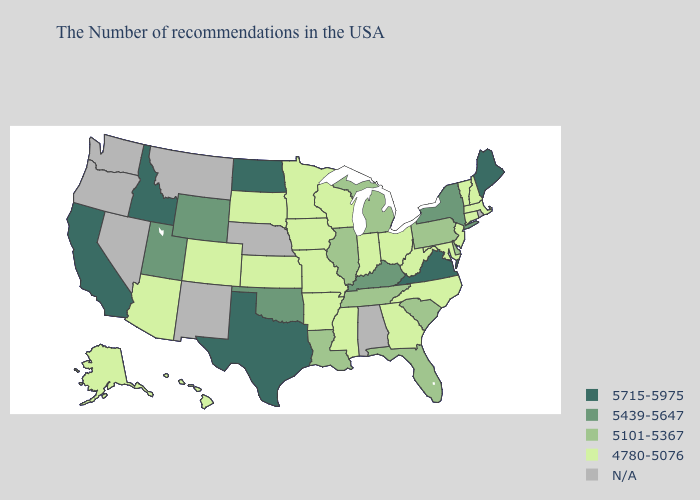Name the states that have a value in the range 5101-5367?
Give a very brief answer. Delaware, Pennsylvania, South Carolina, Florida, Michigan, Tennessee, Illinois, Louisiana. Name the states that have a value in the range 5439-5647?
Be succinct. New York, Kentucky, Oklahoma, Wyoming, Utah. Name the states that have a value in the range 5439-5647?
Write a very short answer. New York, Kentucky, Oklahoma, Wyoming, Utah. What is the lowest value in states that border Virginia?
Answer briefly. 4780-5076. Does Louisiana have the lowest value in the USA?
Keep it brief. No. Among the states that border Oklahoma , which have the highest value?
Answer briefly. Texas. What is the value of Ohio?
Quick response, please. 4780-5076. What is the highest value in states that border Michigan?
Write a very short answer. 4780-5076. What is the value of Wisconsin?
Short answer required. 4780-5076. Does the first symbol in the legend represent the smallest category?
Keep it brief. No. Name the states that have a value in the range 4780-5076?
Short answer required. Massachusetts, New Hampshire, Vermont, Connecticut, New Jersey, Maryland, North Carolina, West Virginia, Ohio, Georgia, Indiana, Wisconsin, Mississippi, Missouri, Arkansas, Minnesota, Iowa, Kansas, South Dakota, Colorado, Arizona, Alaska, Hawaii. What is the highest value in the USA?
Answer briefly. 5715-5975. 